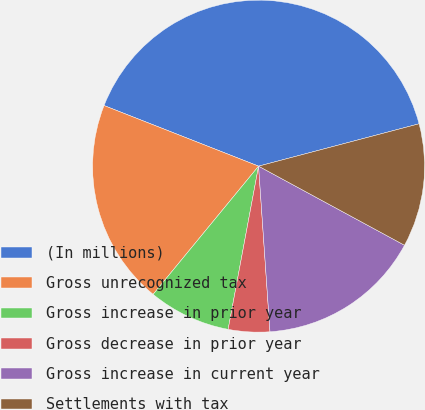<chart> <loc_0><loc_0><loc_500><loc_500><pie_chart><fcel>(In millions)<fcel>Gross unrecognized tax<fcel>Gross increase in prior year<fcel>Gross decrease in prior year<fcel>Gross increase in current year<fcel>Settlements with tax<nl><fcel>39.94%<fcel>19.99%<fcel>8.02%<fcel>4.03%<fcel>16.0%<fcel>12.01%<nl></chart> 